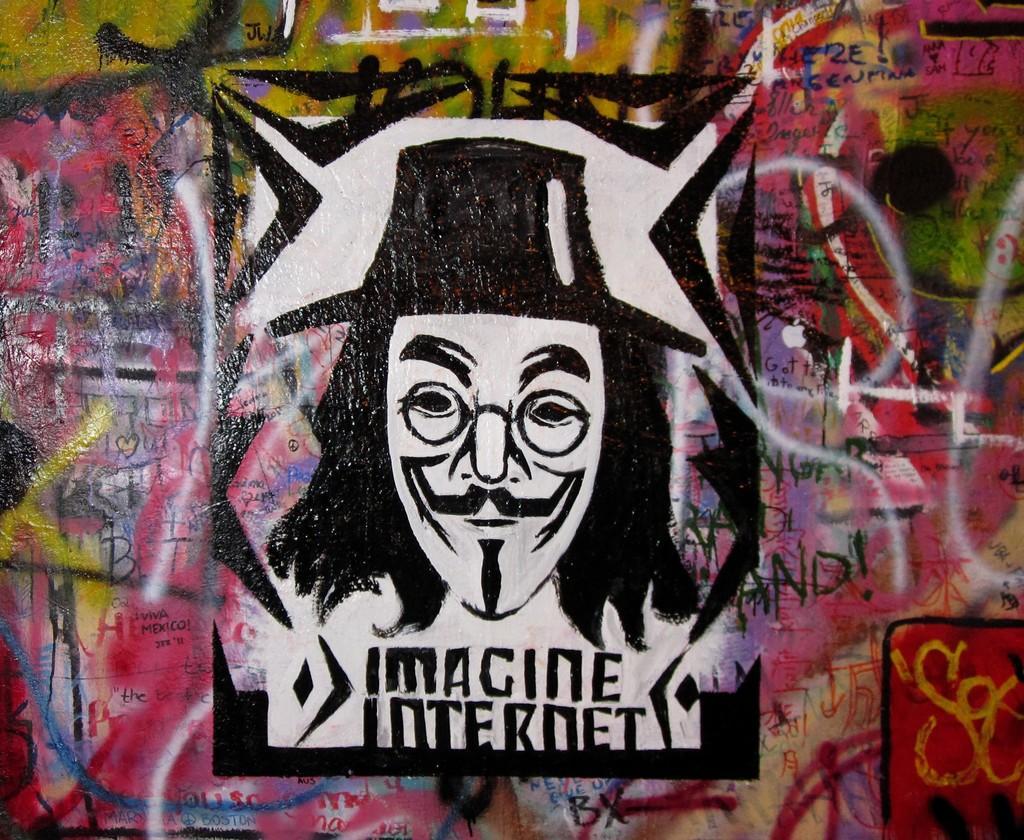Could you give a brief overview of what you see in this image? In this image I can see a wall painting of a person on a wall. 